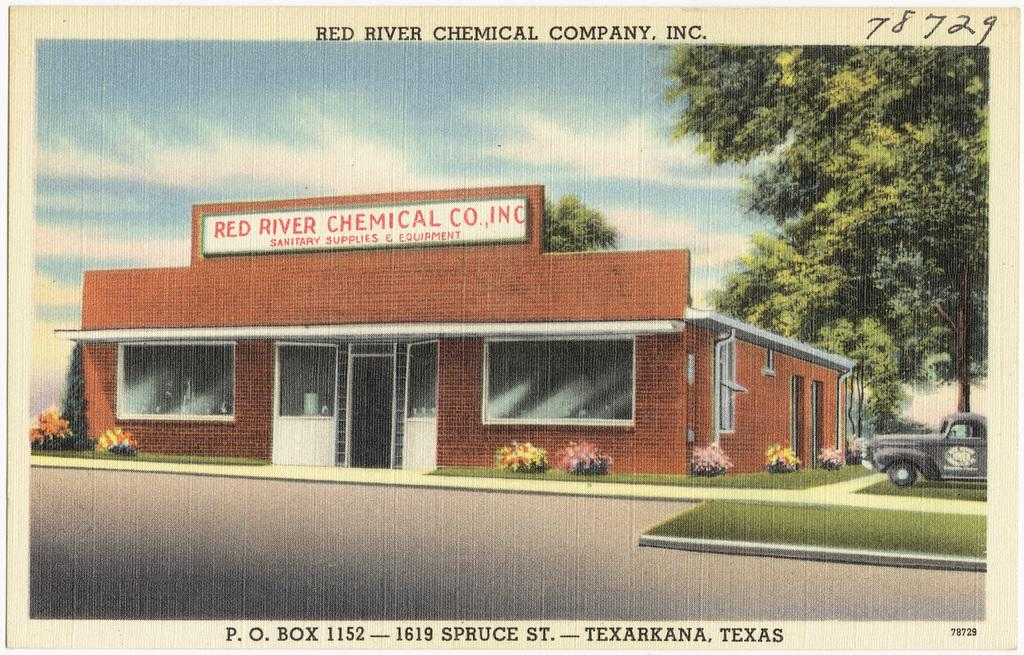What is featured on the poster in the image? The poster contains an image of a house and a car. What other elements can be seen in the image besides the poster? There are plants, trees, and a road visible in the image. What is visible at the top of the image? The sky is visible at the top of the image. How many kittens are playing on the playground in the image? There are no kittens or playground present in the image. What achievements has the achiever in the image accomplished? There is no achiever or mention of achievements in the image. 